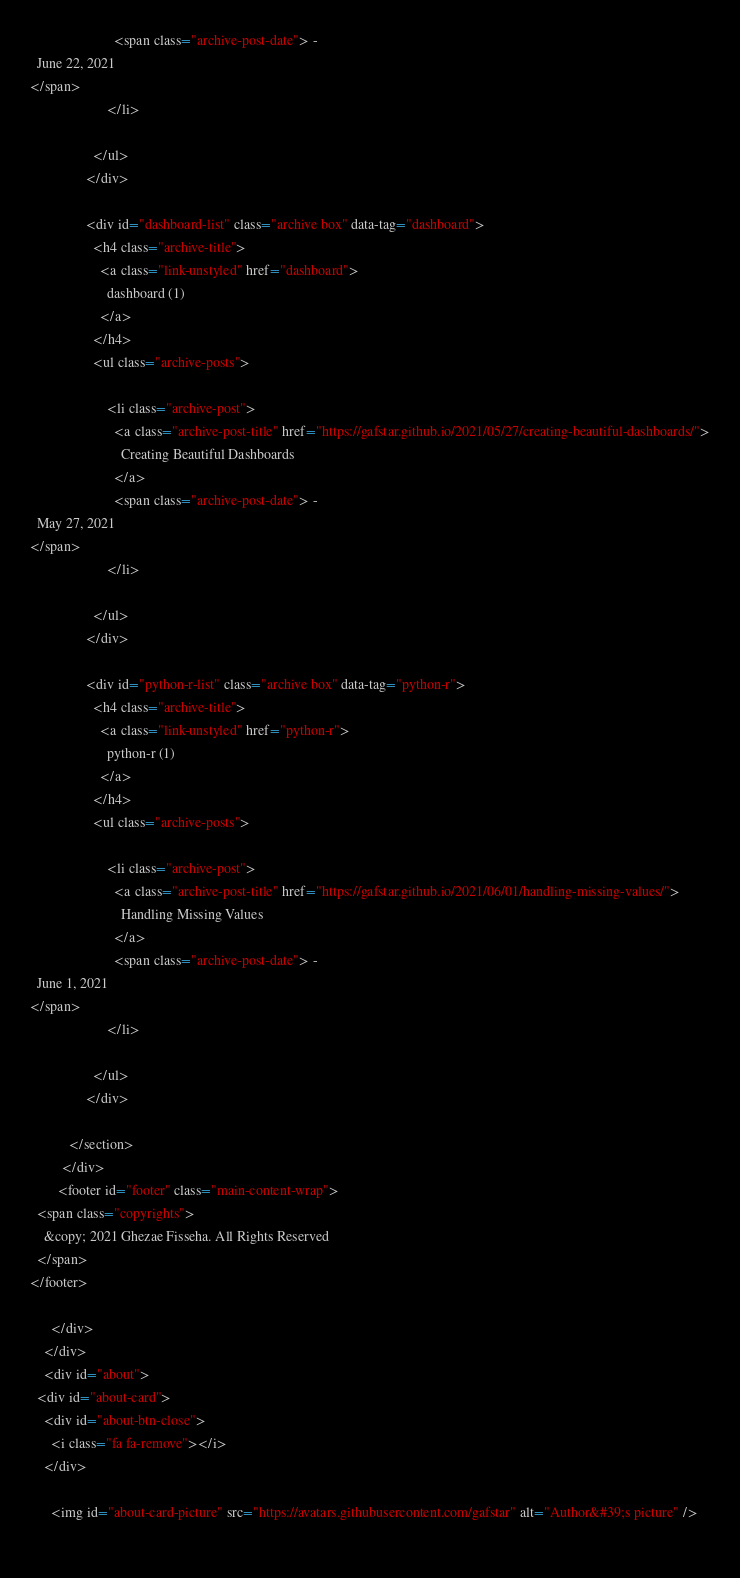<code> <loc_0><loc_0><loc_500><loc_500><_HTML_>                        <span class="archive-post-date"> - 
  June 22, 2021
</span>
                      </li>
                    
                  </ul>
                </div>
              
                <div id="dashboard-list" class="archive box" data-tag="dashboard">
                  <h4 class="archive-title">
                    <a class="link-unstyled" href="dashboard">
                      dashboard (1)
                    </a>
                  </h4>
                  <ul class="archive-posts">
                    
                      <li class="archive-post">
                        <a class="archive-post-title" href="https://gafstar.github.io/2021/05/27/creating-beautiful-dashboards/">
                          Creating Beautiful Dashboards
                        </a>
                        <span class="archive-post-date"> - 
  May 27, 2021
</span>
                      </li>
                    
                  </ul>
                </div>
              
                <div id="python-r-list" class="archive box" data-tag="python-r">
                  <h4 class="archive-title">
                    <a class="link-unstyled" href="python-r">
                      python-r (1)
                    </a>
                  </h4>
                  <ul class="archive-posts">
                    
                      <li class="archive-post">
                        <a class="archive-post-title" href="https://gafstar.github.io/2021/06/01/handling-missing-values/">
                          Handling Missing Values
                        </a>
                        <span class="archive-post-date"> - 
  June 1, 2021
</span>
                      </li>
                    
                  </ul>
                </div>
              
           </section>
         </div>
        <footer id="footer" class="main-content-wrap">
  <span class="copyrights">
    &copy; 2021 Ghezae Fisseha. All Rights Reserved
  </span>
</footer>

      </div>
    </div>
    <div id="about">
  <div id="about-card">
    <div id="about-btn-close">
      <i class="fa fa-remove"></i>
    </div>
    
      <img id="about-card-picture" src="https://avatars.githubusercontent.com/gafstar" alt="Author&#39;s picture" />
    </code> 